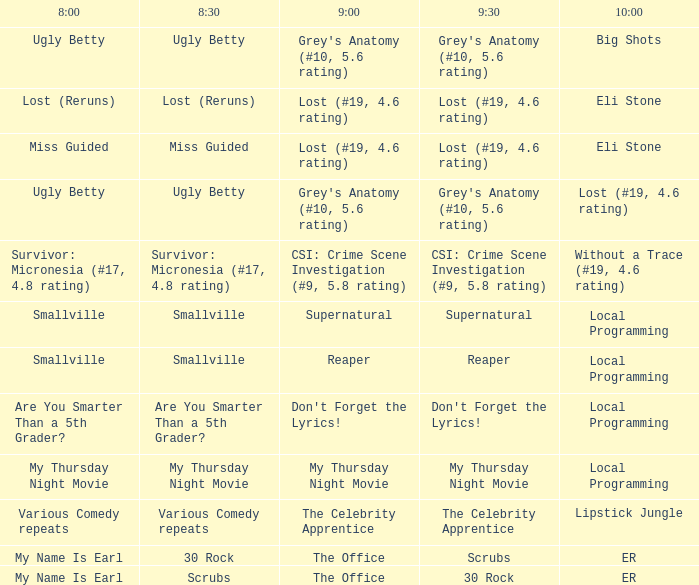What is at 10:00 when at 8:30 it is scrubs? ER. 